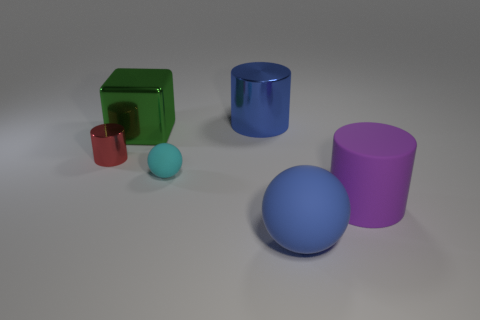Does the matte thing that is left of the large blue cylinder have the same shape as the big blue thing behind the purple object?
Ensure brevity in your answer.  No. What is the size of the cylinder left of the rubber ball that is behind the blue object that is in front of the small metallic object?
Your answer should be very brief. Small. What size is the cylinder that is behind the red cylinder?
Ensure brevity in your answer.  Large. There is a big blue object that is behind the big green cube; what is it made of?
Provide a short and direct response. Metal. What number of purple things are either small rubber blocks or cylinders?
Ensure brevity in your answer.  1. Are the red cylinder and the tiny thing that is on the right side of the big green thing made of the same material?
Provide a short and direct response. No. Are there an equal number of large green things that are in front of the big green shiny cube and tiny balls on the left side of the small cyan ball?
Your answer should be compact. Yes. Does the purple matte thing have the same size as the matte ball behind the blue rubber ball?
Offer a terse response. No. Is the number of big green metal objects that are on the left side of the red shiny thing greater than the number of tiny shiny cylinders?
Your answer should be compact. No. How many cubes are the same size as the red object?
Provide a short and direct response. 0. 